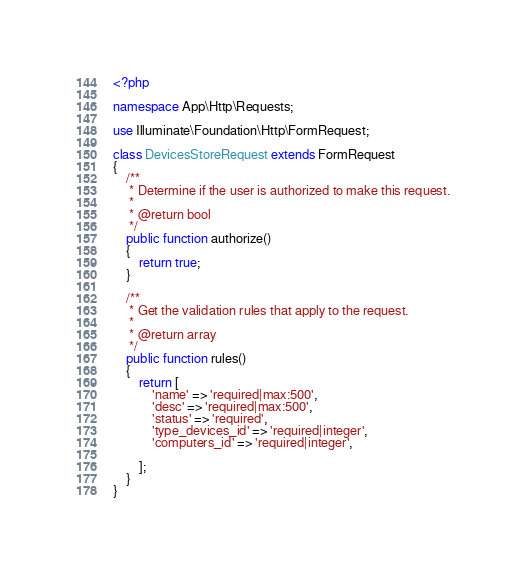Convert code to text. <code><loc_0><loc_0><loc_500><loc_500><_PHP_><?php

namespace App\Http\Requests;

use Illuminate\Foundation\Http\FormRequest;

class DevicesStoreRequest extends FormRequest
{
    /**
     * Determine if the user is authorized to make this request.
     *
     * @return bool
     */
    public function authorize()
    {
        return true;
    }

    /**
     * Get the validation rules that apply to the request.
     *
     * @return array
     */
    public function rules()
    {
        return [
            'name' => 'required|max:500',
            'desc' => 'required|max:500',
            'status' => 'required',
            'type_devices_id' => 'required|integer',
            'computers_id' => 'required|integer',

        ];
    }
}
</code> 